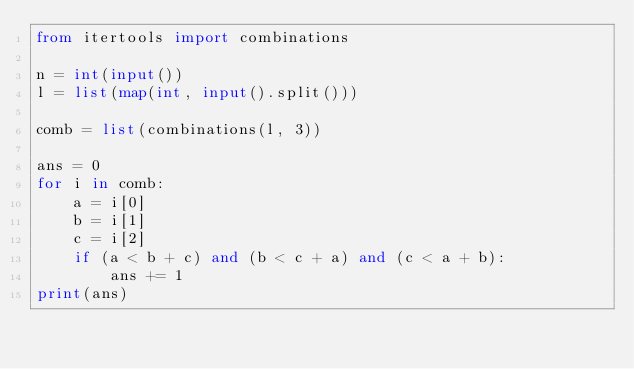<code> <loc_0><loc_0><loc_500><loc_500><_Python_>from itertools import combinations

n = int(input())
l = list(map(int, input().split()))

comb = list(combinations(l, 3))

ans = 0
for i in comb:
    a = i[0]
    b = i[1]
    c = i[2]
    if (a < b + c) and (b < c + a) and (c < a + b):
        ans += 1
print(ans)

</code> 